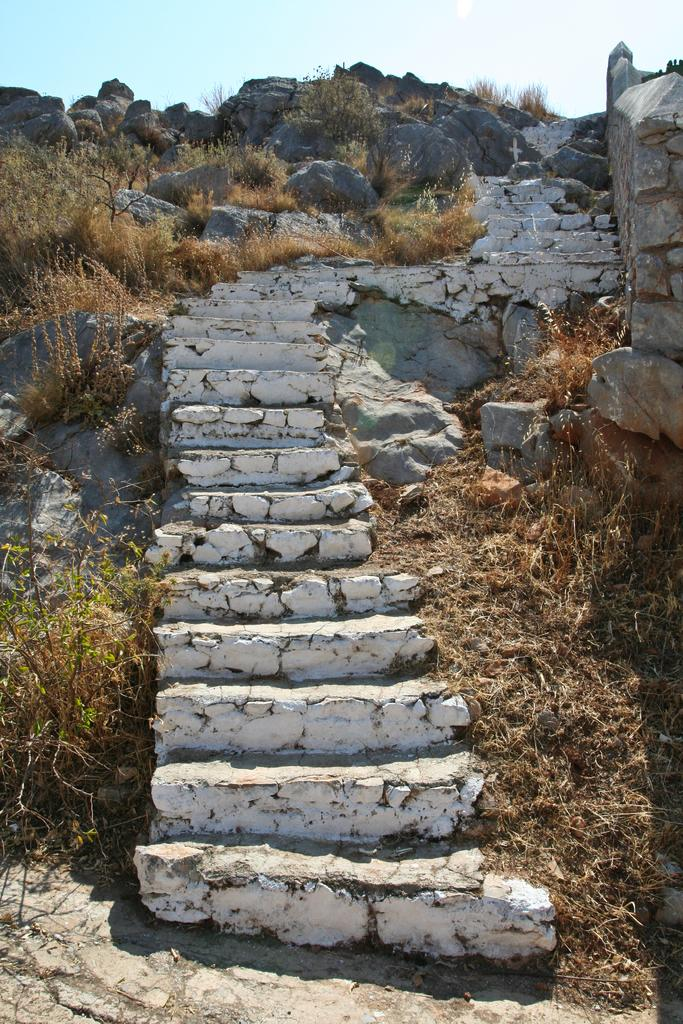What type of structure is present in the image? There are stairs in the image. What type of vegetation can be seen in the image? Dried grass is visible in the image. What other objects can be seen in the image? There are rocks in the image. What is visible in the background of the image? The sky is visible in the image. How does the act of connection impulse the rocks in the image? There is no act, connection, or impulse present in the image; it simply shows stairs, dried grass, rocks, and the sky. 